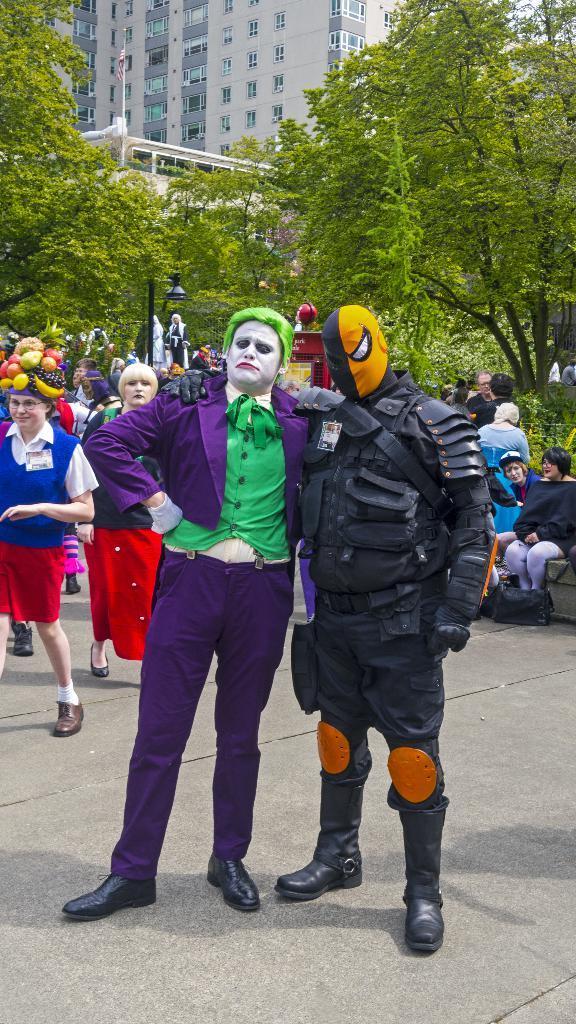Can you describe this image briefly? In this image we can see a few people, some of them are wearing costumes, there is a building, windows, light pole, flag, there are trees, plants. 